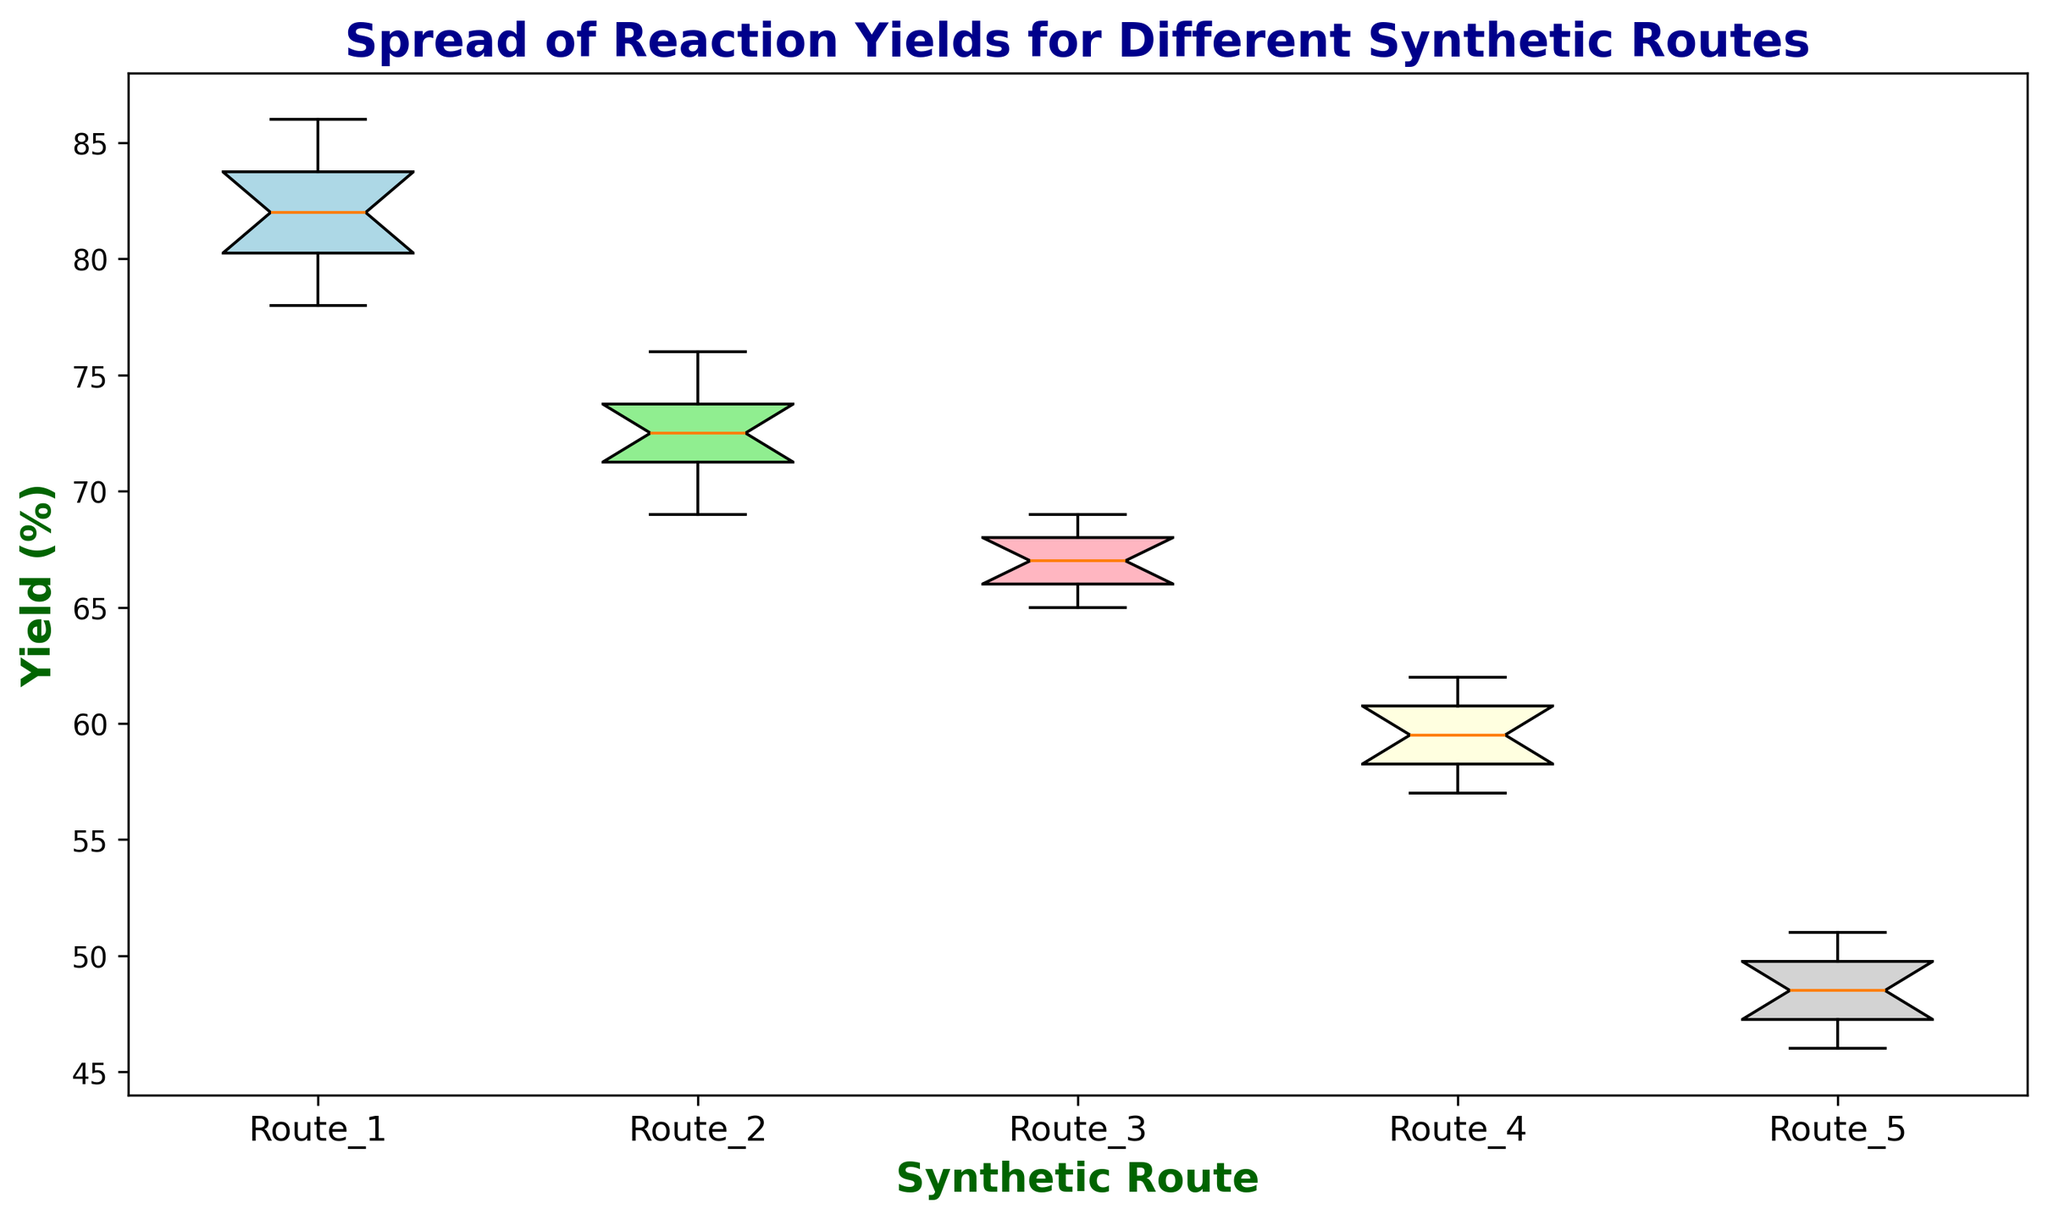Which synthetic route has the highest median yield? To determine the highest median yield, we look at the central line in each box plot. The box plot with the highest central line represents the highest median yield.
Answer: Route 1 Which synthetic route has the widest spread (interquartile range) in yields? The interquartile range (IQR) is the distance between the first and third quartiles (the box edges). The box plot with the widest box determines the widest spread in yields.
Answer: Route 5 Which route has the lowest minimum yield? The minimum yield is represented by the bottom whisker of each box plot. The route with the lowest bottom whisker has the lowest minimum yield.
Answer: Route 5 How does the yield range of Route 2 compare to that of Route 3? The yield range is the distance between the top and bottom whiskers. By comparing the whiskers of Route 2 and Route 3, we observe that Route 2 has a slightly larger range in yields than Route 3.
Answer: Route 2 > Route 3 What is the color of the box plot for Route 4? We identify the color of the box plot for Route 4 by visually inspecting the chart.
Answer: Light yellow Which route shows the least variability in reaction yields? Explain by referring to the lengths of the whiskers and the size of the box plots. Less variability indicates a smaller interquartile range and shorter whiskers. By comparing the box sizes and whisker lengths, we see that Route 3 has the shortest whiskers and one of the smallest boxes, indicating the least variability.
Answer: Route 3 Compare the median yields of Route 1 and Route 2 and state which is higher. The median yield is the central line in each box plot. By comparing Route 1 and Route 2, the central line is higher for Route 1.
Answer: Route 1 What is the total range of yields for Route 5? The total range of yields is the distance between the maximum and minimum values (top and bottom whiskers). For Route 5, this is max (51) - min (46) = 5.
Answer: 5 Which synthetic routes have interquartile ranges (IQR) that overlap? Overlapping IQRs can be seen by the overlapping boxes. Routes 1 and 2, Routes 2 and 3 have overlapping IQRs.
Answer: Routes 1 & 2, Routes 2 & 3 